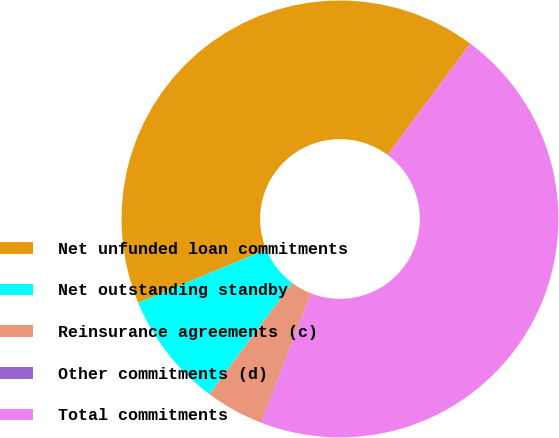Convert chart. <chart><loc_0><loc_0><loc_500><loc_500><pie_chart><fcel>Net unfunded loan commitments<fcel>Net outstanding standby<fcel>Reinsurance agreements (c)<fcel>Other commitments (d)<fcel>Total commitments<nl><fcel>41.44%<fcel>8.54%<fcel>4.29%<fcel>0.04%<fcel>45.69%<nl></chart> 